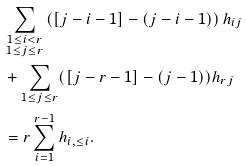<formula> <loc_0><loc_0><loc_500><loc_500>& \sum _ { \substack { 1 \leq i < r \\ 1 \leq j \leq r } } \left ( [ j - i - 1 ] - ( j - i - 1 ) \right ) h _ { i j } \\ & + \sum _ { 1 \leq j \leq r } ( [ j - r - 1 ] - ( j - 1 ) ) h _ { r j } \\ & = r \sum _ { i = 1 } ^ { r - 1 } h _ { i , \leq i } .</formula> 